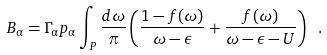Convert formula to latex. <formula><loc_0><loc_0><loc_500><loc_500>B _ { \alpha } = \Gamma _ { \alpha } p _ { \alpha } \int _ { P } \frac { d \omega } { \pi } \left ( \frac { 1 - f ( \omega ) } { \omega - \epsilon } + \frac { f ( \omega ) } { \omega - \epsilon - U } \right ) \ .</formula> 